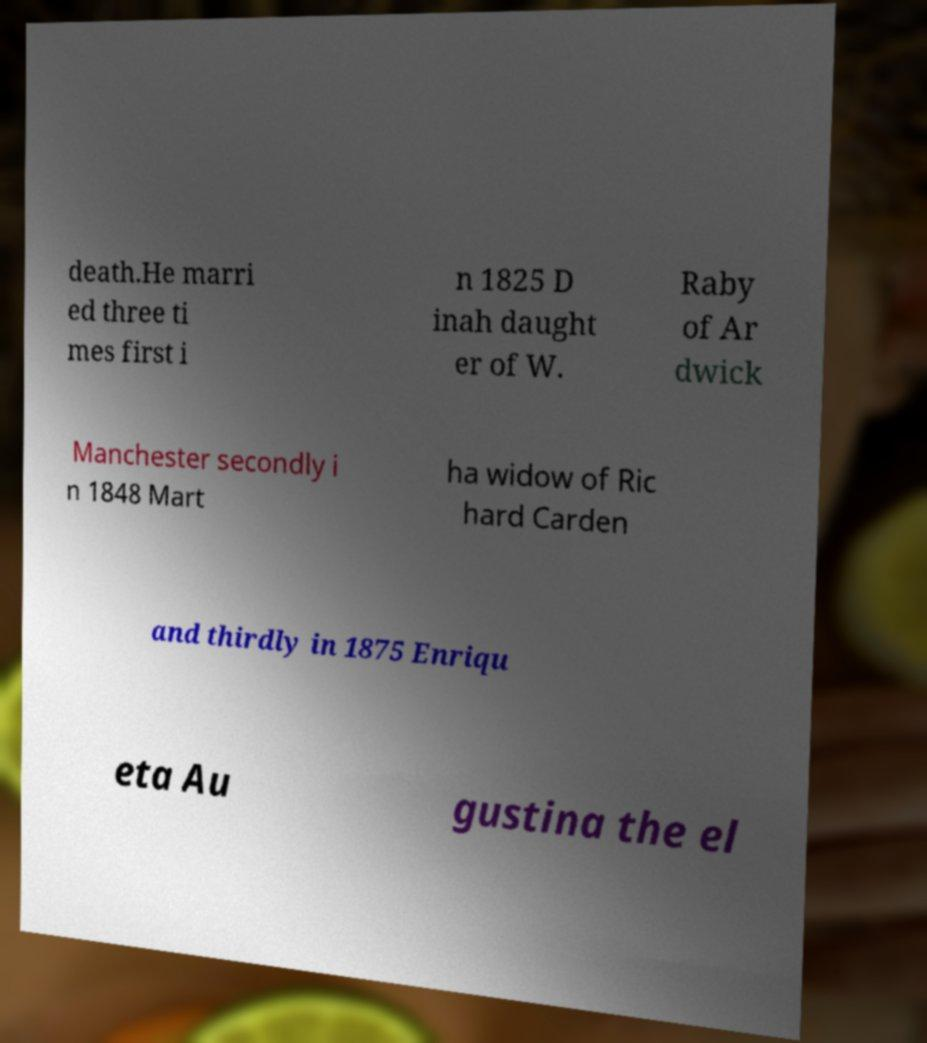Could you assist in decoding the text presented in this image and type it out clearly? death.He marri ed three ti mes first i n 1825 D inah daught er of W. Raby of Ar dwick Manchester secondly i n 1848 Mart ha widow of Ric hard Carden and thirdly in 1875 Enriqu eta Au gustina the el 